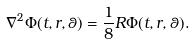Convert formula to latex. <formula><loc_0><loc_0><loc_500><loc_500>\nabla ^ { 2 } \Phi ( t , r , \theta ) = \frac { 1 } { 8 } R \Phi ( t , r , \theta ) .</formula> 